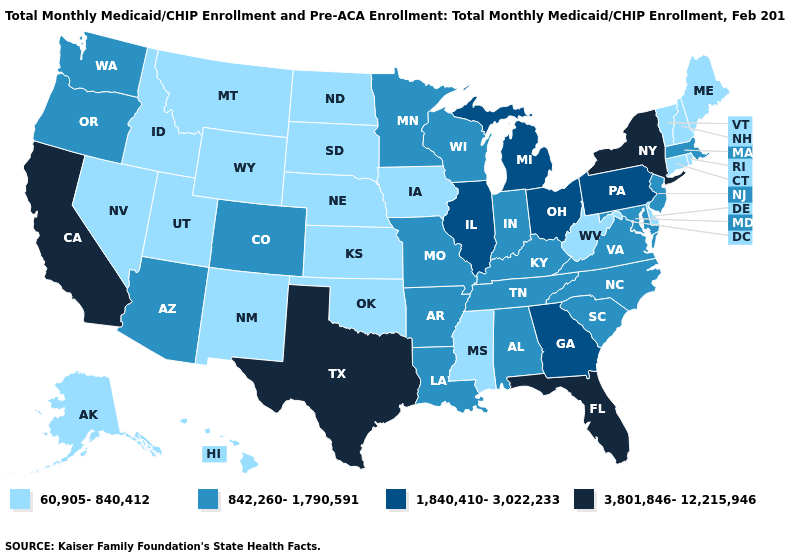Which states have the highest value in the USA?
Be succinct. California, Florida, New York, Texas. Among the states that border Texas , does Louisiana have the lowest value?
Short answer required. No. Among the states that border Louisiana , which have the lowest value?
Answer briefly. Mississippi. Among the states that border Oregon , does Idaho have the lowest value?
Write a very short answer. Yes. Is the legend a continuous bar?
Give a very brief answer. No. What is the lowest value in the MidWest?
Quick response, please. 60,905-840,412. Does the map have missing data?
Quick response, please. No. What is the highest value in the West ?
Concise answer only. 3,801,846-12,215,946. What is the value of Connecticut?
Be succinct. 60,905-840,412. Does Illinois have the lowest value in the USA?
Short answer required. No. Which states hav the highest value in the MidWest?
Keep it brief. Illinois, Michigan, Ohio. Does Hawaii have the highest value in the USA?
Write a very short answer. No. What is the value of Connecticut?
Give a very brief answer. 60,905-840,412. What is the value of Colorado?
Give a very brief answer. 842,260-1,790,591. 